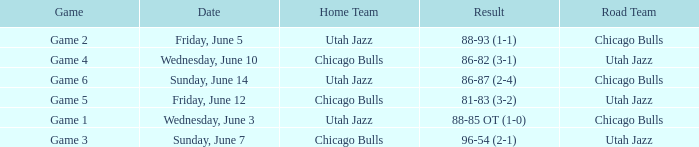What game was associated with the chicago bulls' home side and a scoreline of 81-83 (3-2)? Game 5. 